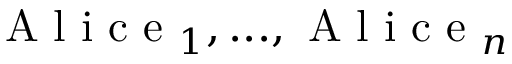<formula> <loc_0><loc_0><loc_500><loc_500>A l i c e _ { 1 } , \dots , A l i c e _ { n }</formula> 